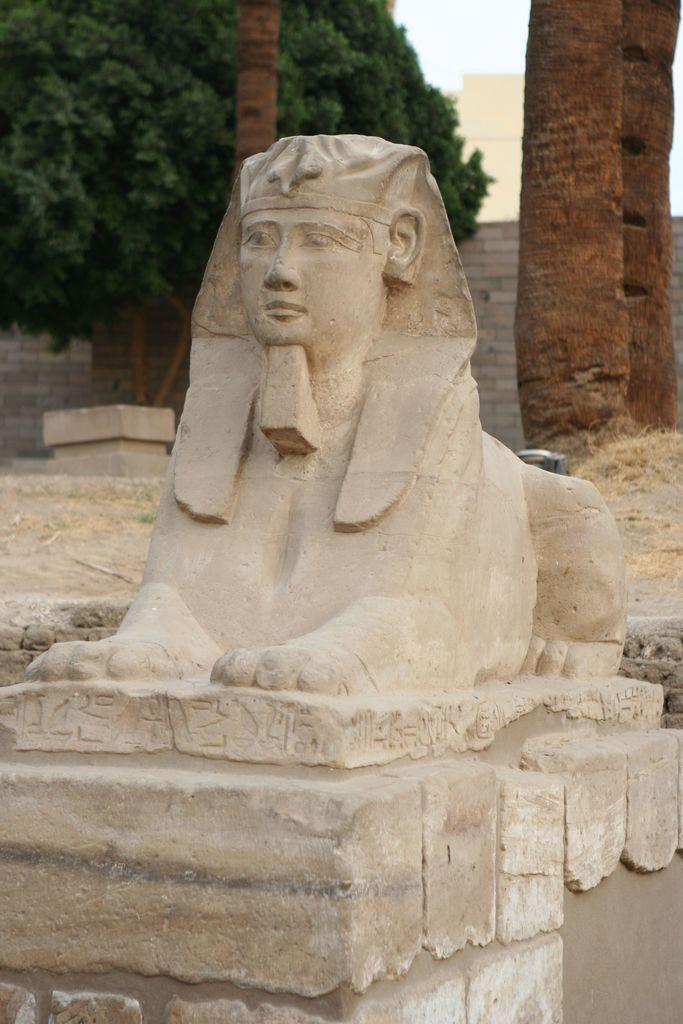Please provide a concise description of this image. Here we can see a sculpture. In the background we can see trees, wall, and sky. 